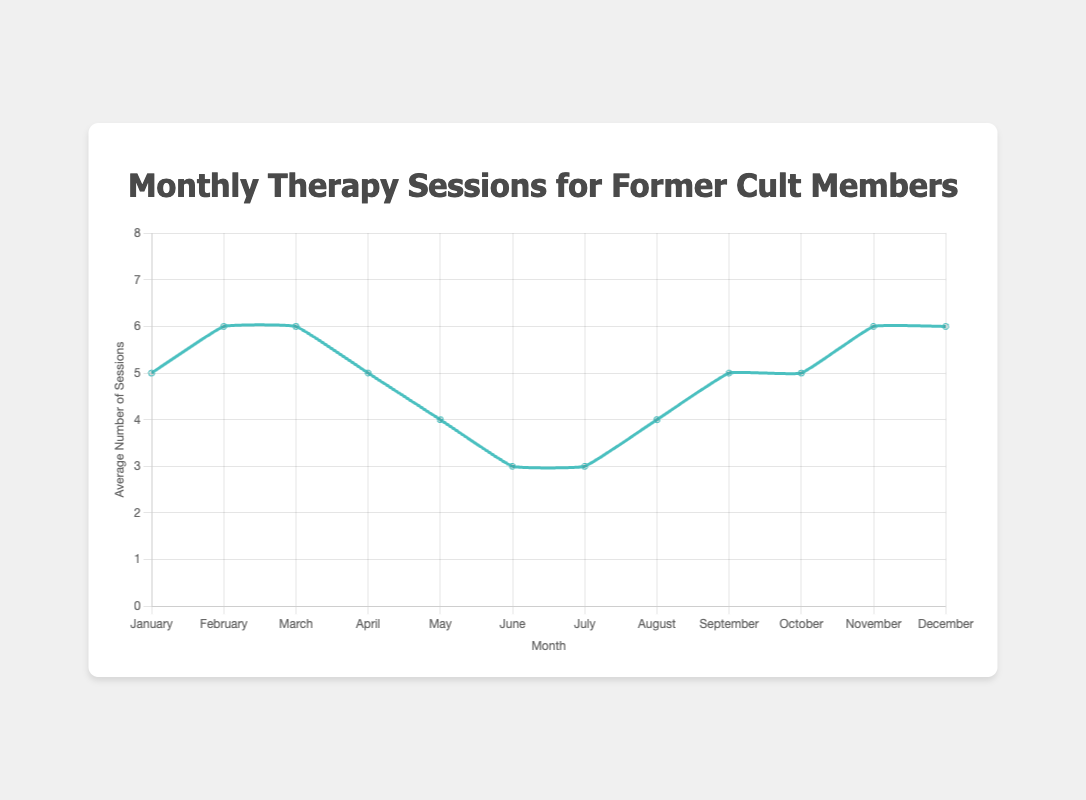What is the highest average number of therapy sessions in any month? Look at the highest point on the line chart; the highest average number of therapy sessions is in February, March, November, and December.
Answer: 6 Which month has the lowest average number of therapy sessions? Identify the lowest point on the line chart; the lowest average is found in June and July.
Answer: 3 What is the total number of average therapy sessions required from January to June? Sum the average sessions from January to June: 5 (Jan) + 6 (Feb) + 6 (Mar) + 5 (Apr) + 4 (May) + 3 (Jun) = 29
Answer: 29 In which months is the average number of therapy sessions equal to 5? Locate months where the line hits the value 5 on the y-axis: January, April, September, and October.
Answer: January, April, September, October What is the difference between the average therapy sessions in March and July? Subtract the average sessions in July from those in March: 6 (Mar) - 3 (Jul) = 3
Answer: 3 What is the trend in the average number of therapy sessions from May to June? From May (4 sessions) to June (3 sessions), the line decreases, indicating a downward trend.
Answer: Downward How does the average number of therapy sessions in August compare to September? Compare the values for both months: August has 4, and September has 5, so there is a decrease followed by an increase.
Answer: August (4), September (5) Calculate the average number of therapy sessions per month for the entire year. Sum all the average sessions and divide by 12: (5+6+6+5+4+3+3+4+5+5+6+6) / 12 = 4.83
Answer: 4.83 Identify the months in which the average number of therapy sessions increases compared to the previous month. Compare each month's data to the previous month: February, August, September, November, and December.
Answer: February, August, September, November, December 